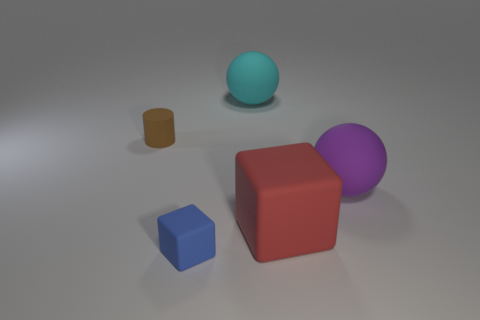Subtract 1 cubes. How many cubes are left? 1 Subtract all cylinders. How many objects are left? 4 Add 4 large purple matte objects. How many objects exist? 9 Add 5 big purple spheres. How many big purple spheres are left? 6 Add 3 blue blocks. How many blue blocks exist? 4 Subtract 0 cyan blocks. How many objects are left? 5 Subtract all blue cubes. Subtract all gray cylinders. How many cubes are left? 1 Subtract all small brown cylinders. Subtract all red matte objects. How many objects are left? 3 